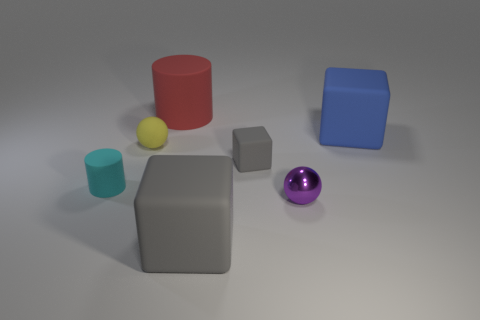What is the material of the sphere that is in front of the rubber cylinder in front of the small cube?
Keep it short and to the point. Metal. Are there any large brown rubber things of the same shape as the red thing?
Ensure brevity in your answer.  No. There is a matte cylinder that is the same size as the purple metal ball; what is its color?
Your answer should be compact. Cyan. How many objects are either gray objects that are on the right side of the big gray rubber thing or gray things that are behind the purple sphere?
Make the answer very short. 1. How many things are either small cyan cylinders or red cylinders?
Give a very brief answer. 2. What is the size of the thing that is on the right side of the small gray matte cube and behind the cyan matte cylinder?
Ensure brevity in your answer.  Large. What number of big blue things are the same material as the big gray thing?
Offer a terse response. 1. What color is the small cylinder that is made of the same material as the yellow thing?
Provide a succinct answer. Cyan. There is a large matte cube that is in front of the rubber sphere; is it the same color as the large rubber cylinder?
Your answer should be very brief. No. There is a blue thing that is behind the small matte cylinder; what material is it?
Your answer should be compact. Rubber. 